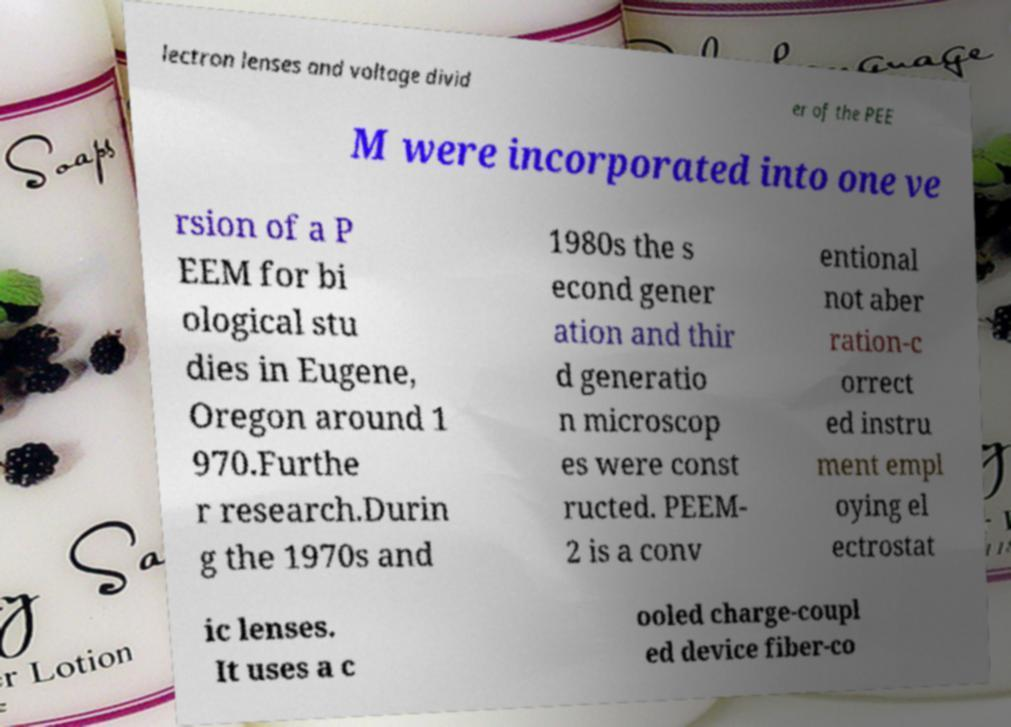Please read and relay the text visible in this image. What does it say? lectron lenses and voltage divid er of the PEE M were incorporated into one ve rsion of a P EEM for bi ological stu dies in Eugene, Oregon around 1 970.Furthe r research.Durin g the 1970s and 1980s the s econd gener ation and thir d generatio n microscop es were const ructed. PEEM- 2 is a conv entional not aber ration-c orrect ed instru ment empl oying el ectrostat ic lenses. It uses a c ooled charge-coupl ed device fiber-co 